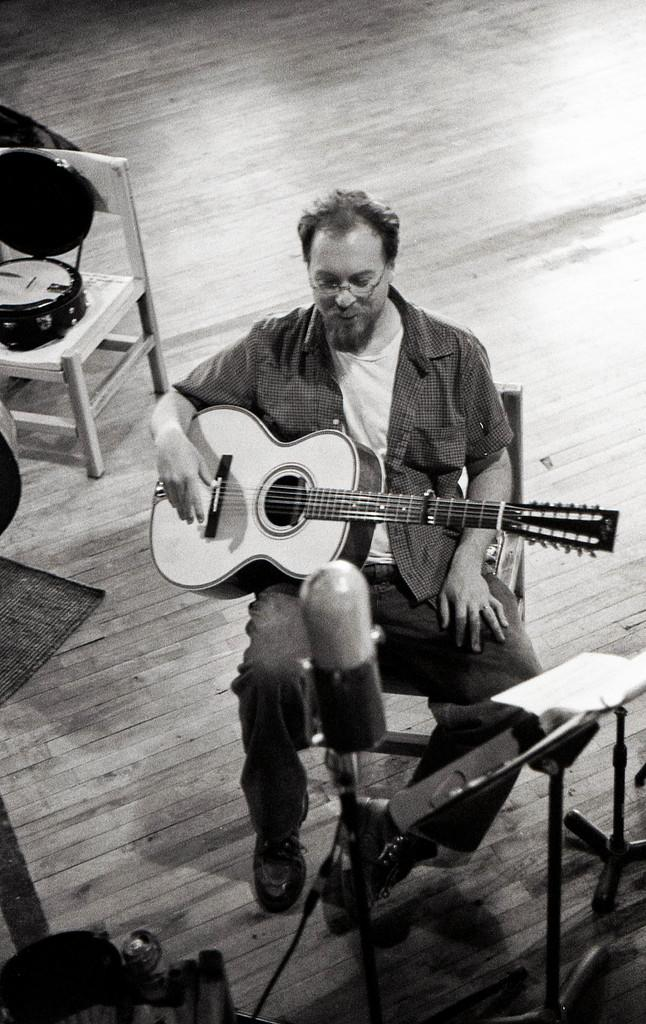Who is present in the image? There is a man in the image. What is the man doing in the image? The man is sitting in the image. What object is the man holding in the image? The man is holding a guitar in the image. What color scheme is used in the image? The image is in black and white color. Can you see any love, rainstorm, or fairies in the image? No, there are no love, rainstorm, or fairies present in the image. 